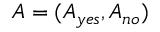Convert formula to latex. <formula><loc_0><loc_0><loc_500><loc_500>A = ( A _ { y e s } , A _ { n o } )</formula> 